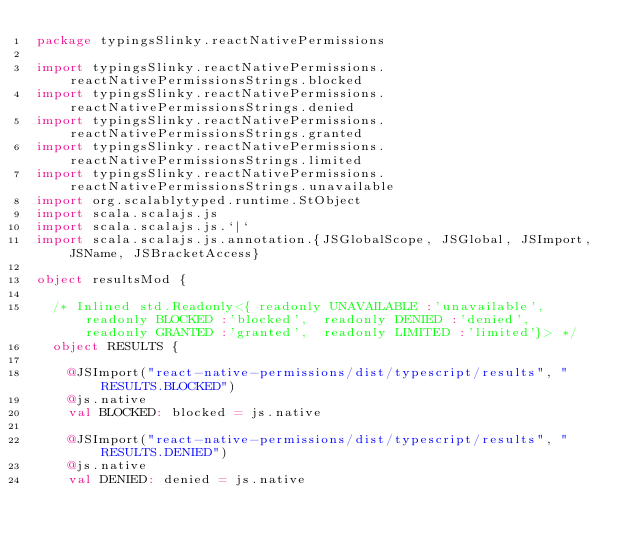Convert code to text. <code><loc_0><loc_0><loc_500><loc_500><_Scala_>package typingsSlinky.reactNativePermissions

import typingsSlinky.reactNativePermissions.reactNativePermissionsStrings.blocked
import typingsSlinky.reactNativePermissions.reactNativePermissionsStrings.denied
import typingsSlinky.reactNativePermissions.reactNativePermissionsStrings.granted
import typingsSlinky.reactNativePermissions.reactNativePermissionsStrings.limited
import typingsSlinky.reactNativePermissions.reactNativePermissionsStrings.unavailable
import org.scalablytyped.runtime.StObject
import scala.scalajs.js
import scala.scalajs.js.`|`
import scala.scalajs.js.annotation.{JSGlobalScope, JSGlobal, JSImport, JSName, JSBracketAccess}

object resultsMod {
  
  /* Inlined std.Readonly<{ readonly UNAVAILABLE :'unavailable',  readonly BLOCKED :'blocked',  readonly DENIED :'denied',  readonly GRANTED :'granted',  readonly LIMITED :'limited'}> */
  object RESULTS {
    
    @JSImport("react-native-permissions/dist/typescript/results", "RESULTS.BLOCKED")
    @js.native
    val BLOCKED: blocked = js.native
    
    @JSImport("react-native-permissions/dist/typescript/results", "RESULTS.DENIED")
    @js.native
    val DENIED: denied = js.native
    </code> 